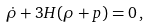Convert formula to latex. <formula><loc_0><loc_0><loc_500><loc_500>\dot { \rho } + 3 H ( \rho + p ) = 0 \, ,</formula> 